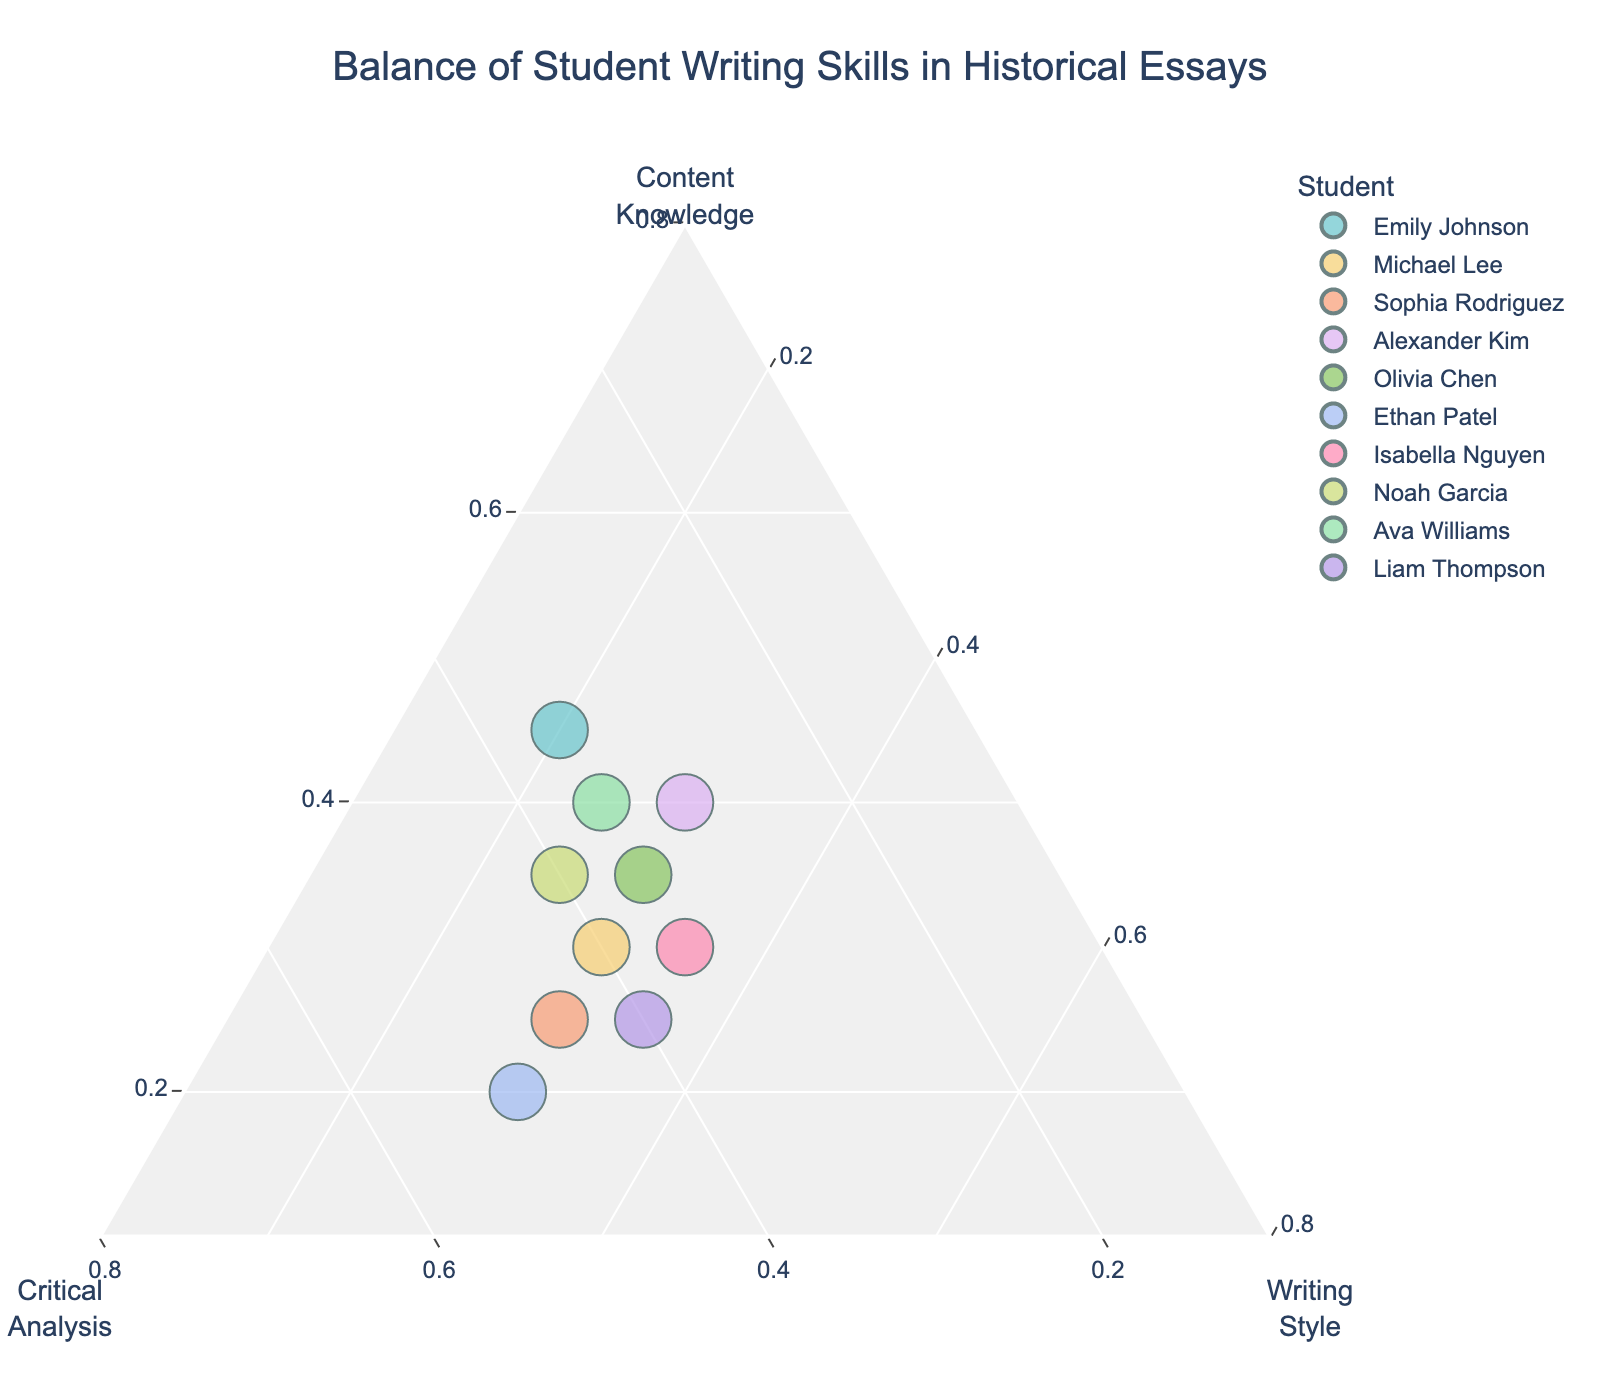How many students are represented in the plot? Count the number of unique data points on the plot or hover over each point to see the student's name. This count will give the total number of students represented.
Answer: 10 Which student has the highest proportion of critical analysis in their writing skills? Look at the axis labeled "Critical Analysis" and identify the point closest to the critical analysis apex. Hovering over the points will reveal the student's name.
Answer: Ethan Patel Are there any students with an equal balance of critical analysis and writing style? Check for points that lie on the line equidistant between the "Critical Analysis" and "Writing Style" axes. Hover over these points to identify the students.
Answer: Michael Lee, Sophia Rodriguez, Isabella Nguyen, Liam Thompson Which student has the most balanced skills across content knowledge, critical analysis, and writing style? Look for a point that is closest to the center of the ternary plot, which indicates equal proportions of all three skills. Hover over this point to see the student's name.
Answer: Olivia Chen What is the average proportion of content knowledge among the students? Sum the proportions of content knowledge for all students and divide by the number of students: (0.45+0.30+0.25+0.40+0.35+0.20+0.30+0.35+0.40+0.25)/10.
Answer: 0.325 Which two students have the most similar skill distributions? Look for points that are closest to each other on the plot. Hover over these points to see the students' names and compare their skill distributions.
Answer: Michael Lee and Sophia Rodriguez Does any student have a writing style proportion equal to or greater than 0.35? Identify points on or beyond the 0.35 line on the "Writing Style" axis. Hover over these points to reveal the students' names.
Answer: Isabella Nguyen, Liam Thompson How does Noah Garcia's skill distribution compare to that of Ava Williams? Locate the points for Noah Garcia and Ava Williams on the plot. Compare their positions relative to each axis to assess the differences and similarities.
Answer: Both have higher critical analysis, Noah Garcia has slightly more critical analysis than Ava Williams, who has more content knowledge What's the median proportion of critical analysis for the students? List all critical analysis proportions (0.35, 0.40, 0.45, 0.30, 0.35, 0.50, 0.35, 0.40, 0.35, 0.40), sort them and find the middle value(s). With 10 data points, the median is the average of the 5th and 6th values.
Answer: 0.375 Which student has the lowest proportion of content knowledge but the highest proportion of critical analysis? Find the point closest to the "Critical Analysis" apex that is furthest from the "Content Knowledge" apex. Hover over to identify the student.
Answer: Ethan Patel 